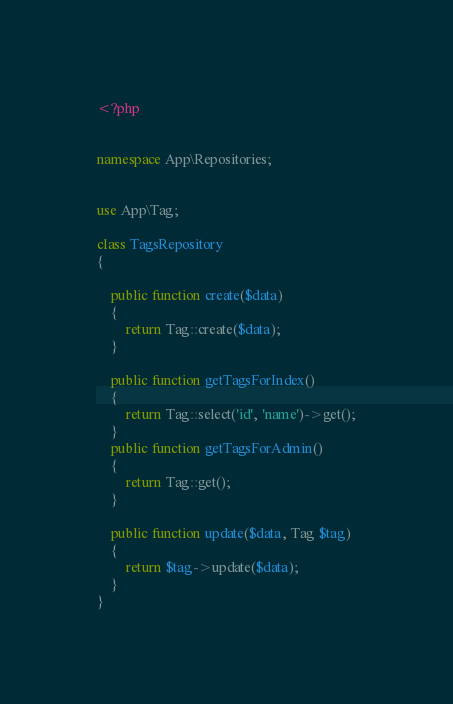Convert code to text. <code><loc_0><loc_0><loc_500><loc_500><_PHP_><?php


namespace App\Repositories;


use App\Tag;

class TagsRepository
{

    public function create($data)
    {
        return Tag::create($data);
    }

    public function getTagsForIndex()
    {
        return Tag::select('id', 'name')->get();
    }
    public function getTagsForAdmin()
    {
        return Tag::get();
    }

    public function update($data, Tag $tag)
    {
        return $tag->update($data);
    }
}
</code> 